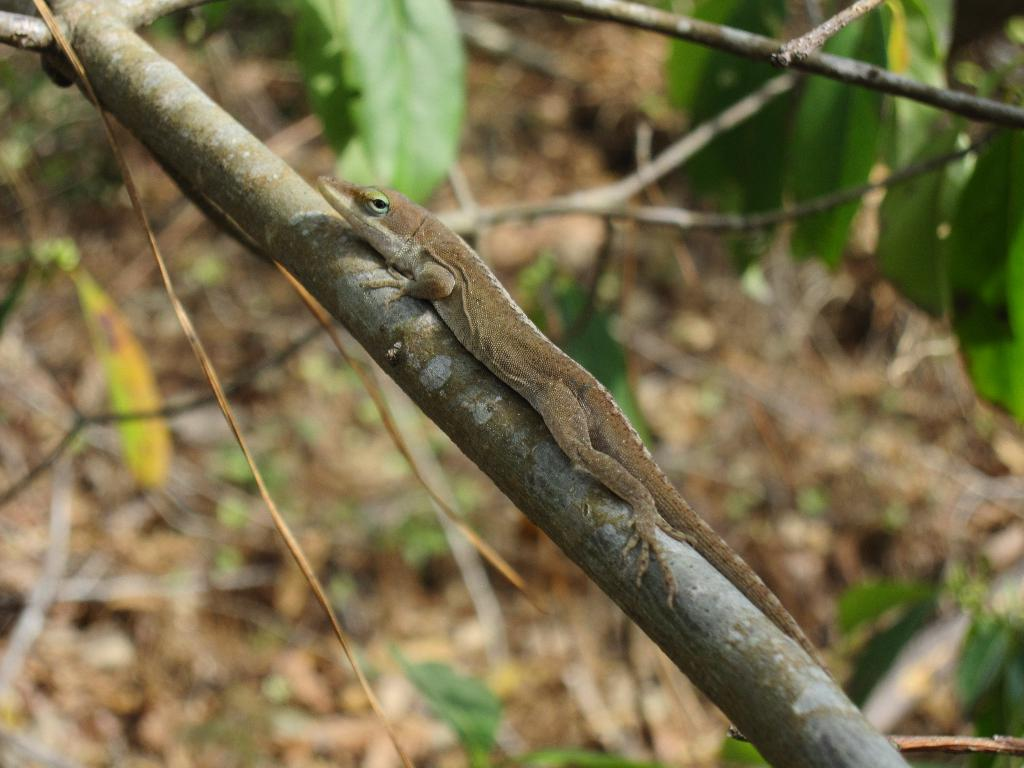What type of animal is in the image? There is a lizard in the image. Where is the lizard located? The lizard is on a branch. What else can be seen in the image besides the lizard? There are leaves in the image. How would you describe the background of the image? The background of the image appears blurry. What type of horn can be seen on the lizard in the image? There is no horn present on the lizard in the image. 